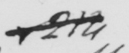Can you tell me what this handwritten text says? &214 